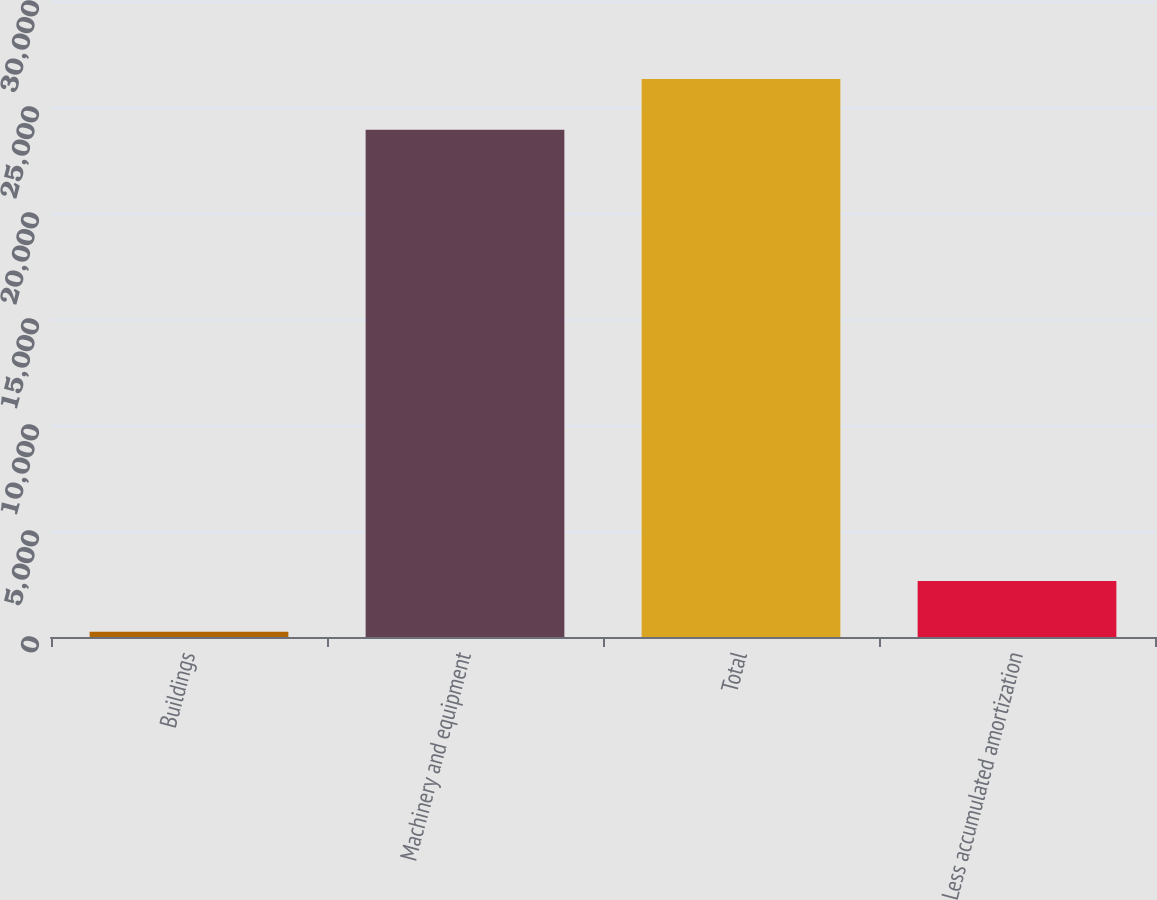Convert chart to OTSL. <chart><loc_0><loc_0><loc_500><loc_500><bar_chart><fcel>Buildings<fcel>Machinery and equipment<fcel>Total<fcel>Less accumulated amortization<nl><fcel>250<fcel>23931<fcel>26324.1<fcel>2643.1<nl></chart> 